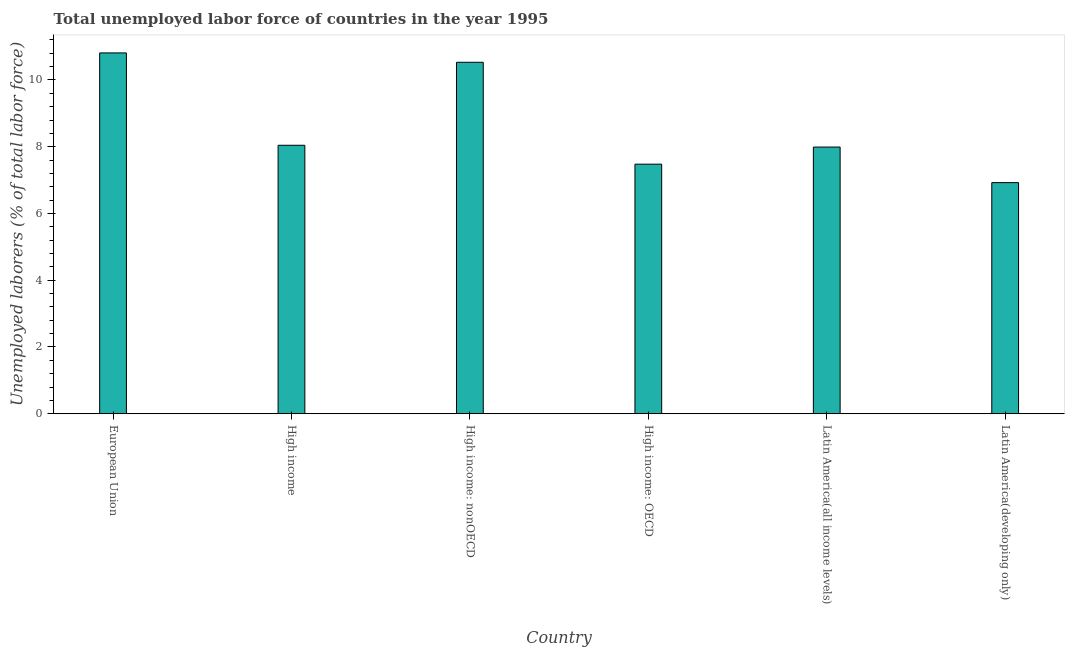Does the graph contain grids?
Provide a short and direct response. No. What is the title of the graph?
Your response must be concise. Total unemployed labor force of countries in the year 1995. What is the label or title of the X-axis?
Make the answer very short. Country. What is the label or title of the Y-axis?
Your response must be concise. Unemployed laborers (% of total labor force). What is the total unemployed labour force in High income: OECD?
Ensure brevity in your answer.  7.48. Across all countries, what is the maximum total unemployed labour force?
Offer a very short reply. 10.81. Across all countries, what is the minimum total unemployed labour force?
Ensure brevity in your answer.  6.92. In which country was the total unemployed labour force minimum?
Keep it short and to the point. Latin America(developing only). What is the sum of the total unemployed labour force?
Offer a very short reply. 51.78. What is the difference between the total unemployed labour force in European Union and Latin America(developing only)?
Keep it short and to the point. 3.89. What is the average total unemployed labour force per country?
Give a very brief answer. 8.63. What is the median total unemployed labour force?
Your response must be concise. 8.02. In how many countries, is the total unemployed labour force greater than 1.2 %?
Your answer should be compact. 6. What is the ratio of the total unemployed labour force in High income to that in High income: nonOECD?
Make the answer very short. 0.76. Is the total unemployed labour force in European Union less than that in High income?
Provide a succinct answer. No. What is the difference between the highest and the second highest total unemployed labour force?
Your response must be concise. 0.28. Is the sum of the total unemployed labour force in High income and Latin America(developing only) greater than the maximum total unemployed labour force across all countries?
Offer a terse response. Yes. What is the difference between the highest and the lowest total unemployed labour force?
Your response must be concise. 3.89. In how many countries, is the total unemployed labour force greater than the average total unemployed labour force taken over all countries?
Ensure brevity in your answer.  2. How many bars are there?
Your response must be concise. 6. Are the values on the major ticks of Y-axis written in scientific E-notation?
Provide a short and direct response. No. What is the Unemployed laborers (% of total labor force) in European Union?
Provide a short and direct response. 10.81. What is the Unemployed laborers (% of total labor force) in High income?
Provide a short and direct response. 8.04. What is the Unemployed laborers (% of total labor force) of High income: nonOECD?
Offer a very short reply. 10.53. What is the Unemployed laborers (% of total labor force) of High income: OECD?
Ensure brevity in your answer.  7.48. What is the Unemployed laborers (% of total labor force) of Latin America(all income levels)?
Give a very brief answer. 7.99. What is the Unemployed laborers (% of total labor force) of Latin America(developing only)?
Your answer should be compact. 6.92. What is the difference between the Unemployed laborers (% of total labor force) in European Union and High income?
Keep it short and to the point. 2.77. What is the difference between the Unemployed laborers (% of total labor force) in European Union and High income: nonOECD?
Make the answer very short. 0.28. What is the difference between the Unemployed laborers (% of total labor force) in European Union and High income: OECD?
Your answer should be very brief. 3.33. What is the difference between the Unemployed laborers (% of total labor force) in European Union and Latin America(all income levels)?
Your response must be concise. 2.82. What is the difference between the Unemployed laborers (% of total labor force) in European Union and Latin America(developing only)?
Provide a succinct answer. 3.89. What is the difference between the Unemployed laborers (% of total labor force) in High income and High income: nonOECD?
Make the answer very short. -2.49. What is the difference between the Unemployed laborers (% of total labor force) in High income and High income: OECD?
Give a very brief answer. 0.57. What is the difference between the Unemployed laborers (% of total labor force) in High income and Latin America(all income levels)?
Provide a short and direct response. 0.05. What is the difference between the Unemployed laborers (% of total labor force) in High income and Latin America(developing only)?
Provide a short and direct response. 1.12. What is the difference between the Unemployed laborers (% of total labor force) in High income: nonOECD and High income: OECD?
Offer a very short reply. 3.05. What is the difference between the Unemployed laborers (% of total labor force) in High income: nonOECD and Latin America(all income levels)?
Provide a short and direct response. 2.54. What is the difference between the Unemployed laborers (% of total labor force) in High income: nonOECD and Latin America(developing only)?
Provide a short and direct response. 3.61. What is the difference between the Unemployed laborers (% of total labor force) in High income: OECD and Latin America(all income levels)?
Offer a terse response. -0.51. What is the difference between the Unemployed laborers (% of total labor force) in High income: OECD and Latin America(developing only)?
Offer a terse response. 0.55. What is the difference between the Unemployed laborers (% of total labor force) in Latin America(all income levels) and Latin America(developing only)?
Make the answer very short. 1.07. What is the ratio of the Unemployed laborers (% of total labor force) in European Union to that in High income?
Your answer should be very brief. 1.34. What is the ratio of the Unemployed laborers (% of total labor force) in European Union to that in High income: OECD?
Provide a succinct answer. 1.45. What is the ratio of the Unemployed laborers (% of total labor force) in European Union to that in Latin America(all income levels)?
Provide a short and direct response. 1.35. What is the ratio of the Unemployed laborers (% of total labor force) in European Union to that in Latin America(developing only)?
Provide a succinct answer. 1.56. What is the ratio of the Unemployed laborers (% of total labor force) in High income to that in High income: nonOECD?
Offer a very short reply. 0.76. What is the ratio of the Unemployed laborers (% of total labor force) in High income to that in High income: OECD?
Ensure brevity in your answer.  1.08. What is the ratio of the Unemployed laborers (% of total labor force) in High income to that in Latin America(all income levels)?
Give a very brief answer. 1.01. What is the ratio of the Unemployed laborers (% of total labor force) in High income to that in Latin America(developing only)?
Offer a very short reply. 1.16. What is the ratio of the Unemployed laborers (% of total labor force) in High income: nonOECD to that in High income: OECD?
Provide a short and direct response. 1.41. What is the ratio of the Unemployed laborers (% of total labor force) in High income: nonOECD to that in Latin America(all income levels)?
Make the answer very short. 1.32. What is the ratio of the Unemployed laborers (% of total labor force) in High income: nonOECD to that in Latin America(developing only)?
Your response must be concise. 1.52. What is the ratio of the Unemployed laborers (% of total labor force) in High income: OECD to that in Latin America(all income levels)?
Give a very brief answer. 0.94. What is the ratio of the Unemployed laborers (% of total labor force) in High income: OECD to that in Latin America(developing only)?
Your answer should be very brief. 1.08. What is the ratio of the Unemployed laborers (% of total labor force) in Latin America(all income levels) to that in Latin America(developing only)?
Provide a short and direct response. 1.15. 